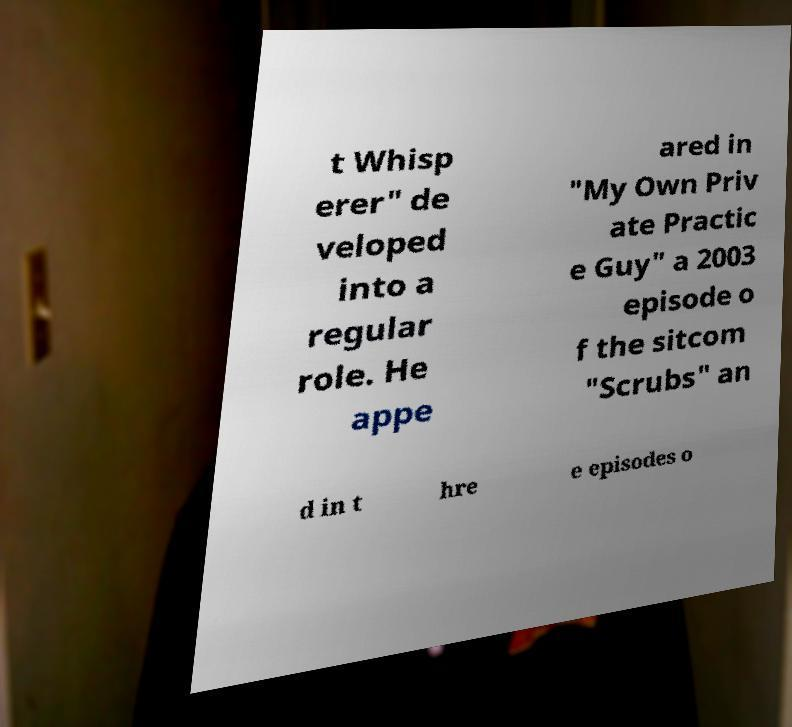What messages or text are displayed in this image? I need them in a readable, typed format. t Whisp erer" de veloped into a regular role. He appe ared in "My Own Priv ate Practic e Guy" a 2003 episode o f the sitcom "Scrubs" an d in t hre e episodes o 